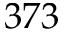<formula> <loc_0><loc_0><loc_500><loc_500>3 7 3</formula> 